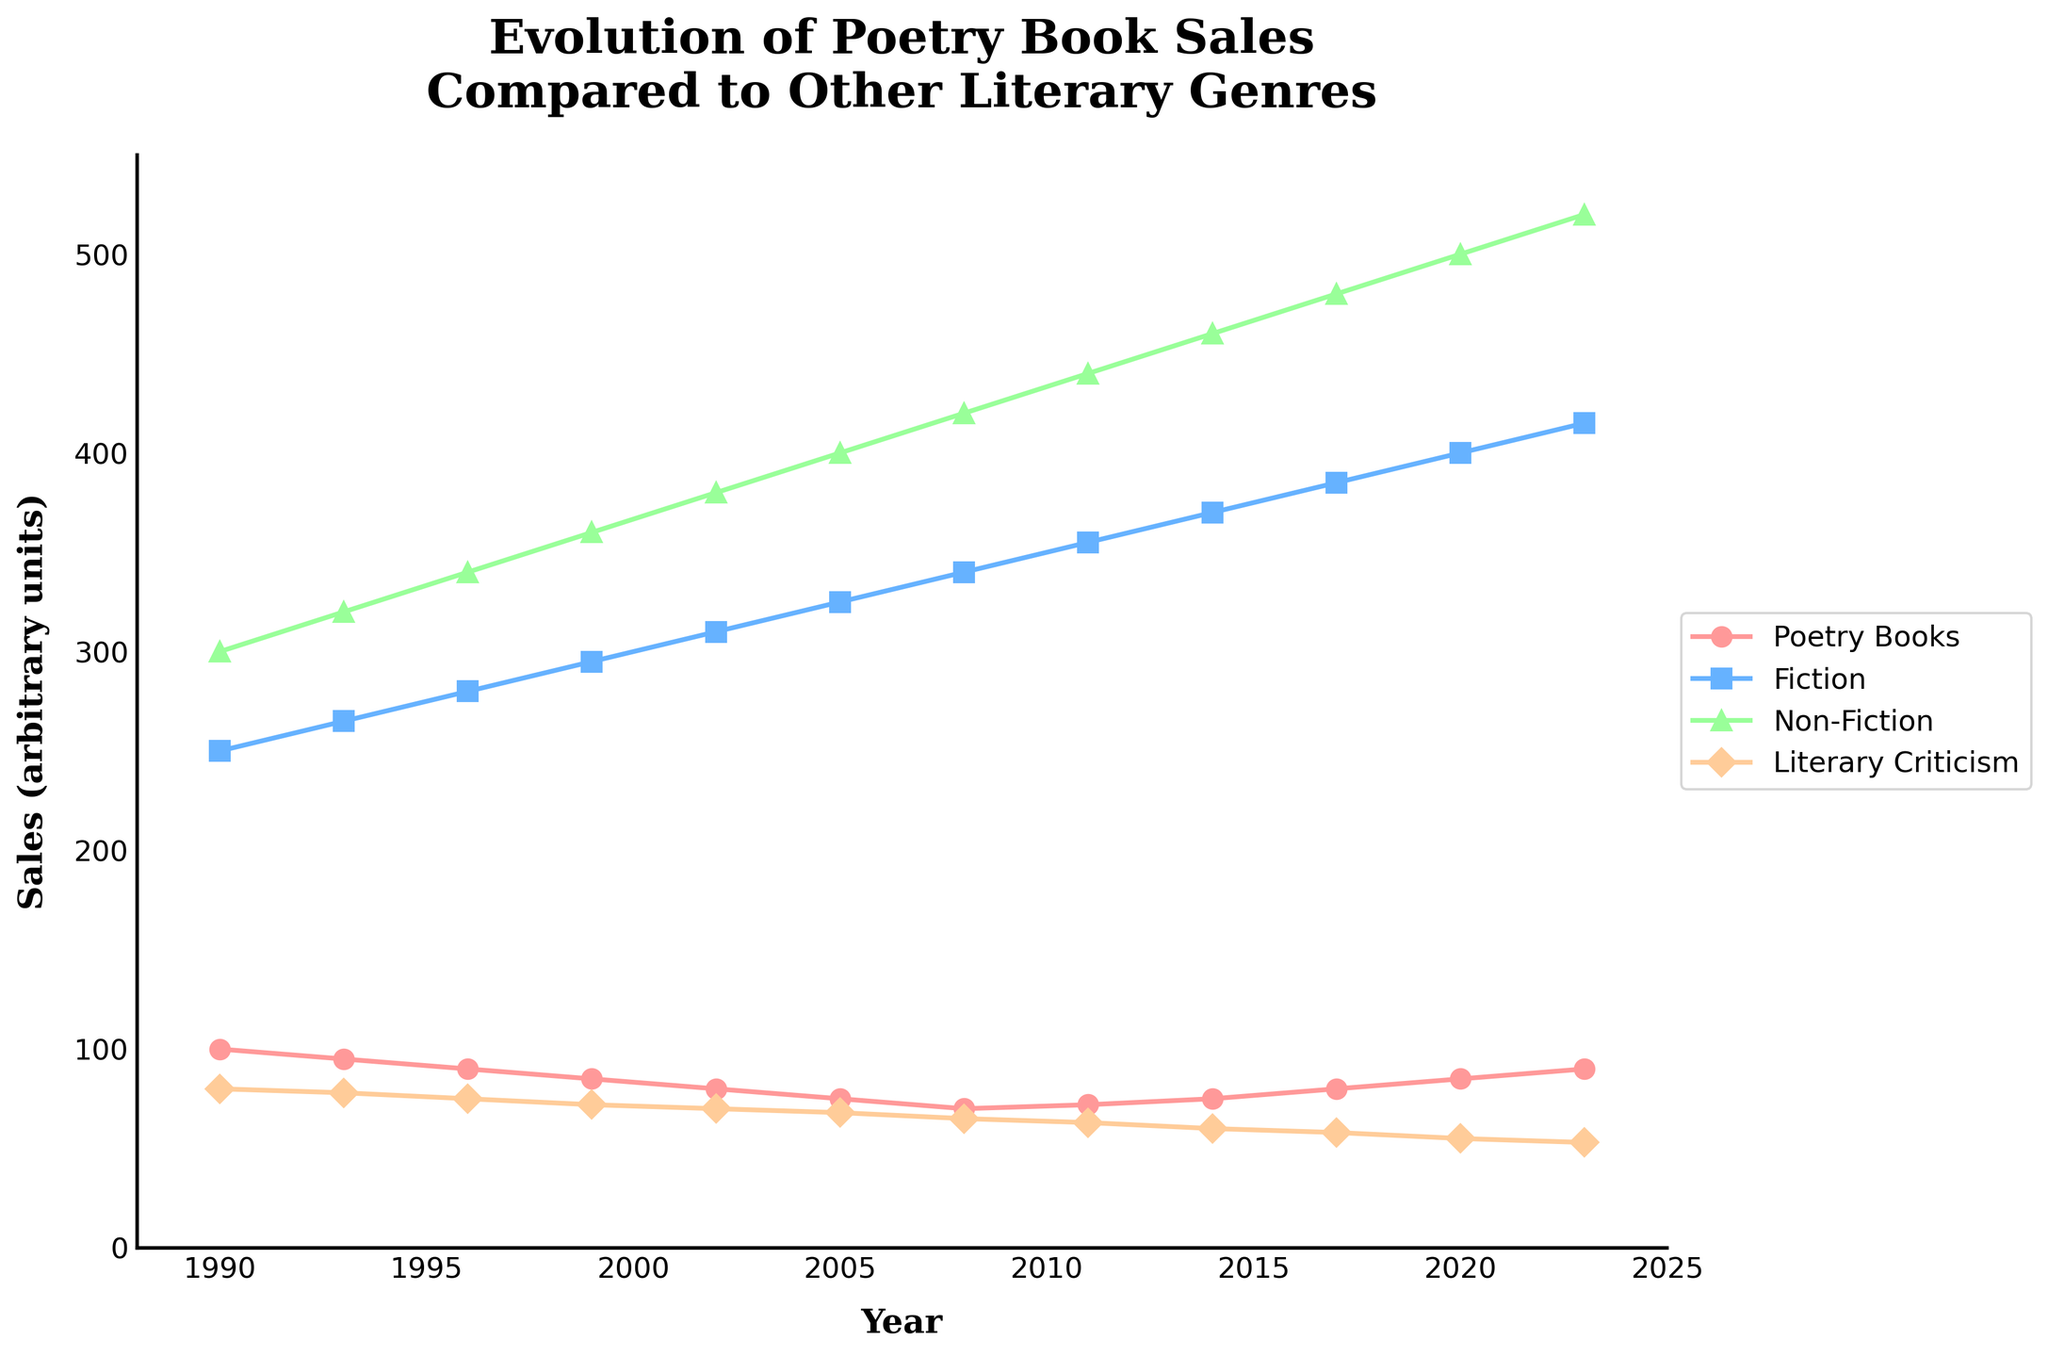What's the general trend of poetry book sales from 1990 to 2023? The line for poetry books generally declines from 1990 to 2008, reaching a low point, and then gradually increases from 2008 to 2023.
Answer: Decline initially, then gradual increase Which literary genre had the highest sales throughout the entire period? By observing the lines, Non-Fiction consistently has the highest sales among all the genres from 1990 to 2023 since its line is always at the top.
Answer: Non-Fiction How much did fiction book sales increase from 1990 to 2023? The sales of fiction books in 1990 were 250 units, and in 2023, they are 415 units. The increase is 415 - 250 = 165 units.
Answer: 165 units Which year had the lowest point for poetry book sales, and what was the sales figure for that year? The line for poetry books is lowest in 2008 with a sales figure of 70 units.
Answer: 2008, 70 units Compare the sales of literary criticism books in 1990 and 2023. Which year had higher sales and by how much? In 1990, sales were 80 units, and in 2023, they were 53 units. 1990 had higher sales by 80 - 53 = 27 units.
Answer: 1990 by 27 units What is the overall trend of fiction book sales from 1990 to 2023? The fiction line shows a consistent upward trend, indicating a gradual increase in sales from 250 units in 1990 to 415 units in 2023.
Answer: Consistent upward trend Between which consecutive years did poetry book sales see the most significant increase? By observing the yearly changes in the poetry line, the largest increase happens from 2017 to 2020, where sales went from 80 to 85 units.
Answer: From 2017 to 2020 Which genre experienced a decrease in sales between 1990 and 2023? By comparing the starting and ending points of the lines for each genre, only Literary Criticism shows a decline from 80 units in 1990 to 53 units in 2023.
Answer: Literary Criticism What was the difference in sales between Fiction and Poetry books in 2020? The sales of Fiction books in 2020 were 400 units and Poetry books were 85 units. The difference is 400 - 85 = 315 units.
Answer: 315 units Based on visual attributes, which genre is represented by the green line and marker in the chart? By looking at the color and markers, the green line with circle markers represents Poetry Books.
Answer: Poetry Books 